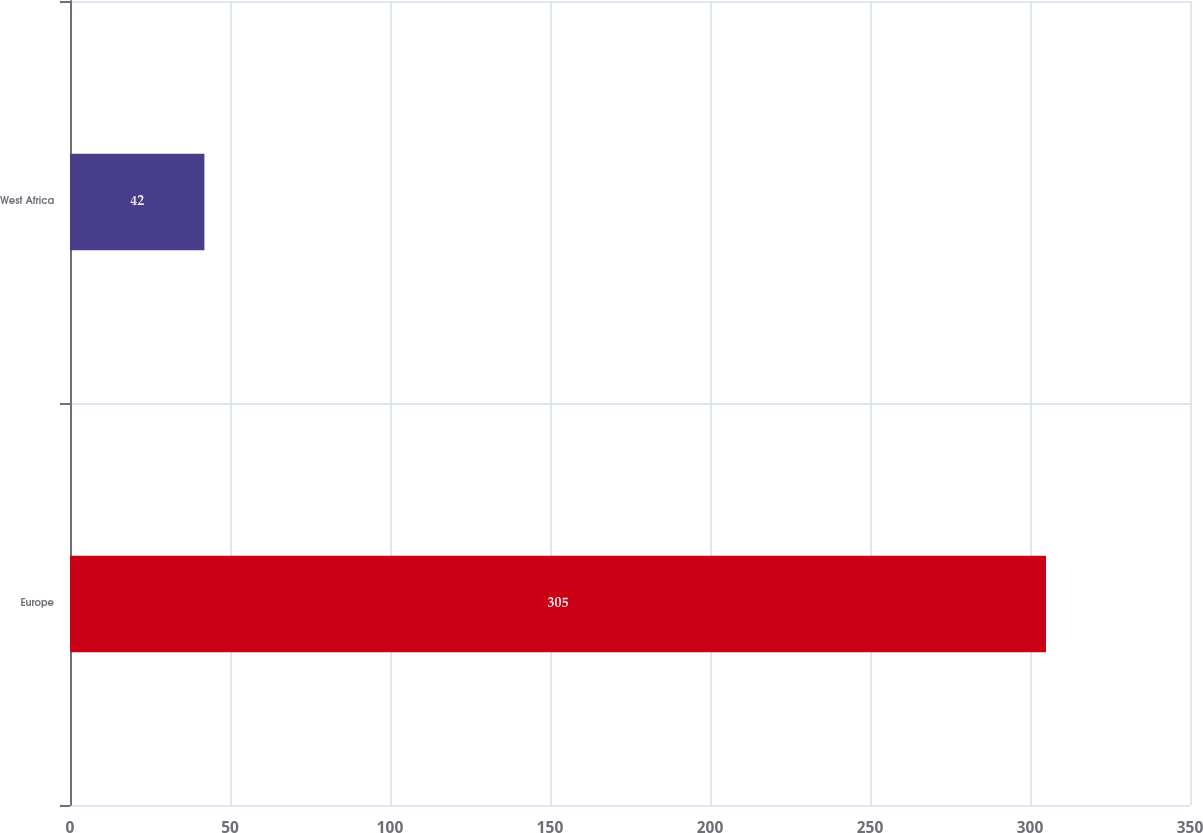<chart> <loc_0><loc_0><loc_500><loc_500><bar_chart><fcel>Europe<fcel>West Africa<nl><fcel>305<fcel>42<nl></chart> 